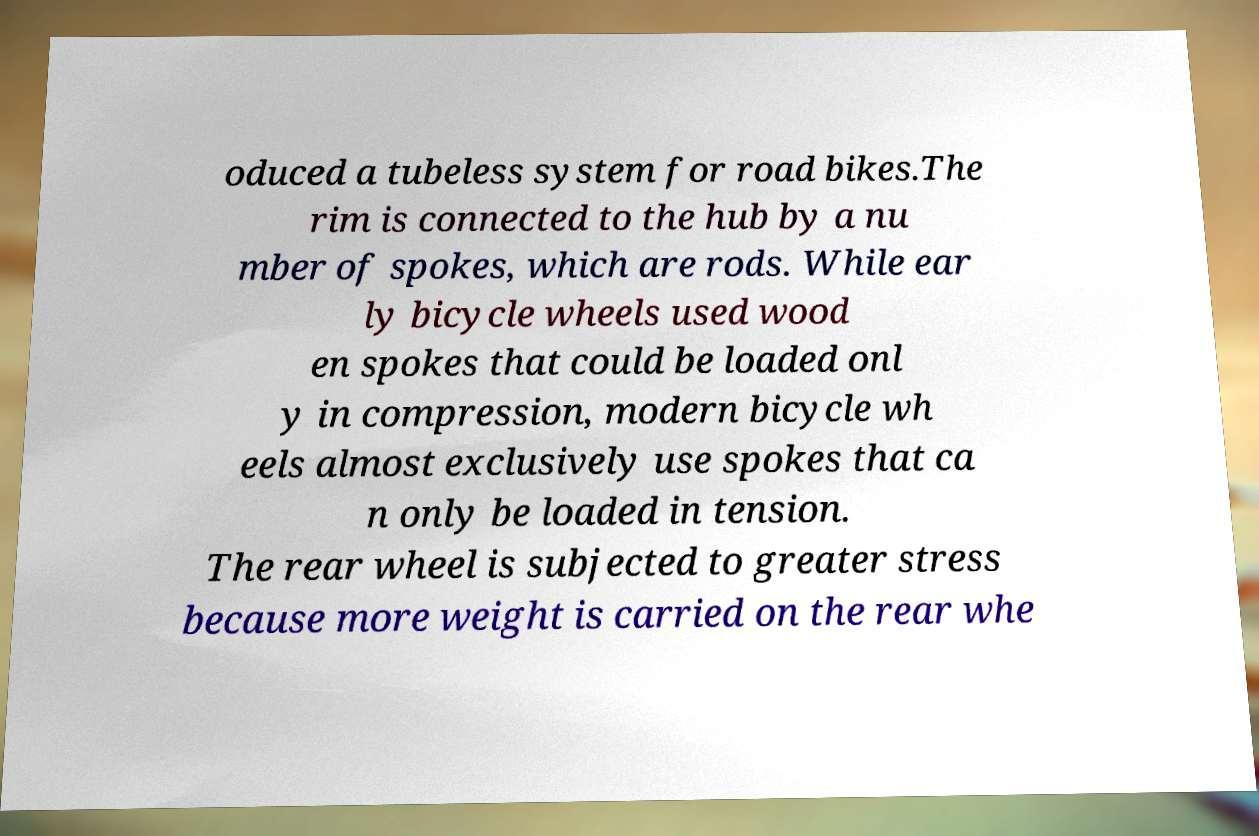Please read and relay the text visible in this image. What does it say? oduced a tubeless system for road bikes.The rim is connected to the hub by a nu mber of spokes, which are rods. While ear ly bicycle wheels used wood en spokes that could be loaded onl y in compression, modern bicycle wh eels almost exclusively use spokes that ca n only be loaded in tension. The rear wheel is subjected to greater stress because more weight is carried on the rear whe 